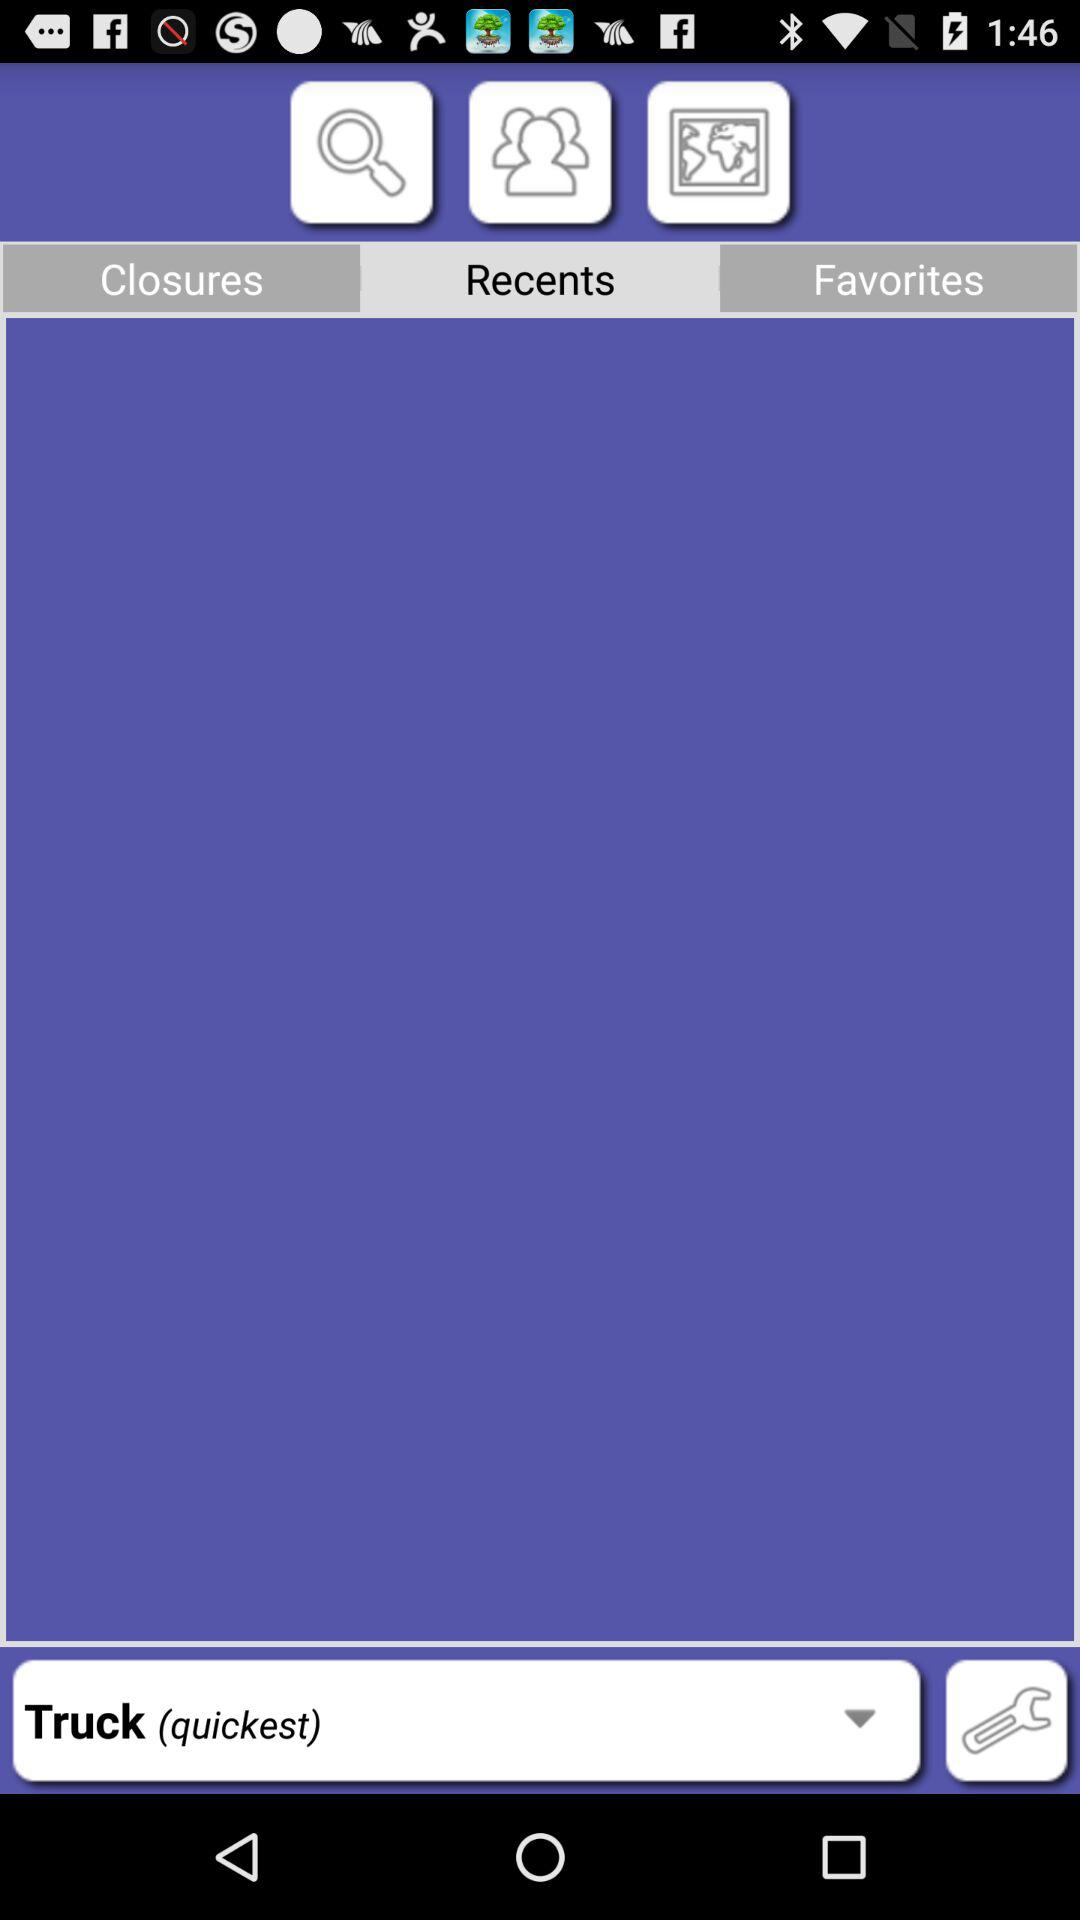What is the selected word in "Recents"? The selected word in "Recents" is "Truck (quickest)". 